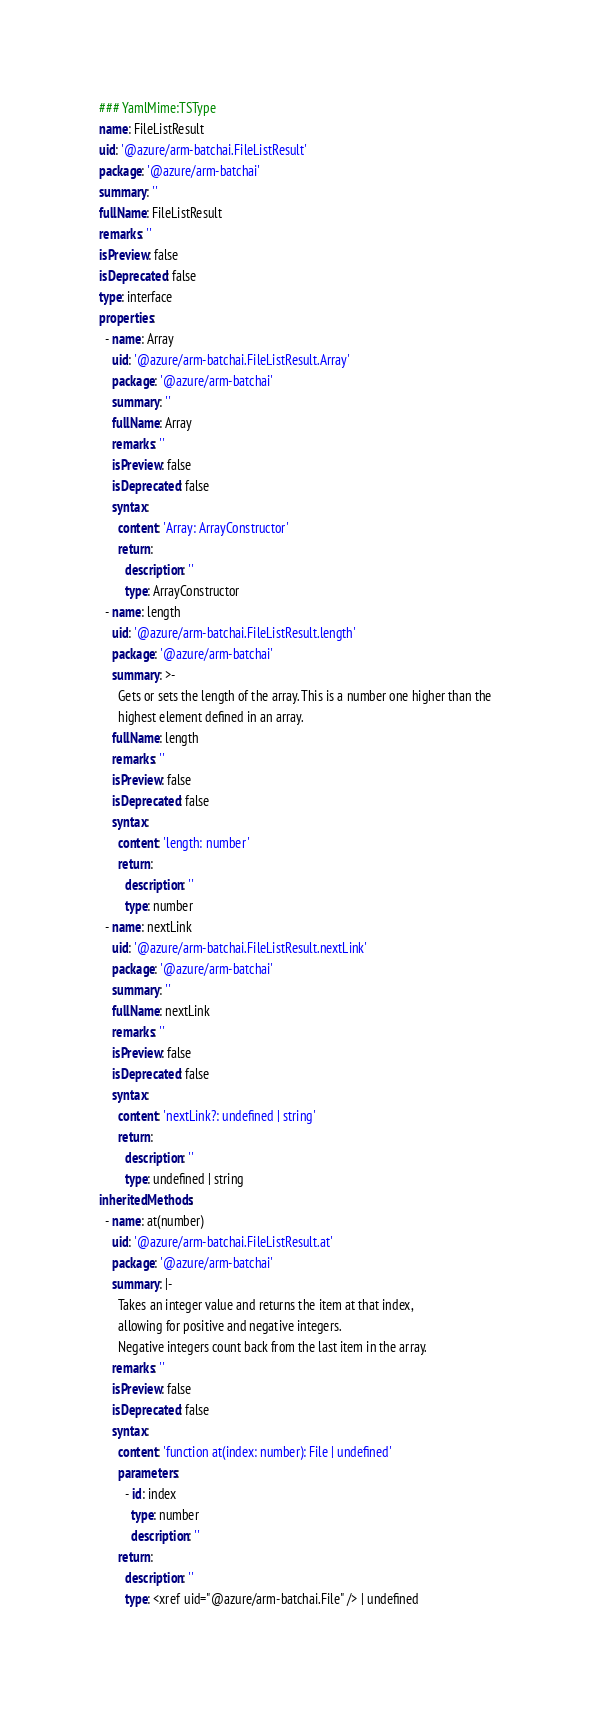<code> <loc_0><loc_0><loc_500><loc_500><_YAML_>### YamlMime:TSType
name: FileListResult
uid: '@azure/arm-batchai.FileListResult'
package: '@azure/arm-batchai'
summary: ''
fullName: FileListResult
remarks: ''
isPreview: false
isDeprecated: false
type: interface
properties:
  - name: Array
    uid: '@azure/arm-batchai.FileListResult.Array'
    package: '@azure/arm-batchai'
    summary: ''
    fullName: Array
    remarks: ''
    isPreview: false
    isDeprecated: false
    syntax:
      content: 'Array: ArrayConstructor'
      return:
        description: ''
        type: ArrayConstructor
  - name: length
    uid: '@azure/arm-batchai.FileListResult.length'
    package: '@azure/arm-batchai'
    summary: >-
      Gets or sets the length of the array. This is a number one higher than the
      highest element defined in an array.
    fullName: length
    remarks: ''
    isPreview: false
    isDeprecated: false
    syntax:
      content: 'length: number'
      return:
        description: ''
        type: number
  - name: nextLink
    uid: '@azure/arm-batchai.FileListResult.nextLink'
    package: '@azure/arm-batchai'
    summary: ''
    fullName: nextLink
    remarks: ''
    isPreview: false
    isDeprecated: false
    syntax:
      content: 'nextLink?: undefined | string'
      return:
        description: ''
        type: undefined | string
inheritedMethods:
  - name: at(number)
    uid: '@azure/arm-batchai.FileListResult.at'
    package: '@azure/arm-batchai'
    summary: |-
      Takes an integer value and returns the item at that index,
      allowing for positive and negative integers.
      Negative integers count back from the last item in the array.
    remarks: ''
    isPreview: false
    isDeprecated: false
    syntax:
      content: 'function at(index: number): File | undefined'
      parameters:
        - id: index
          type: number
          description: ''
      return:
        description: ''
        type: <xref uid="@azure/arm-batchai.File" /> | undefined</code> 